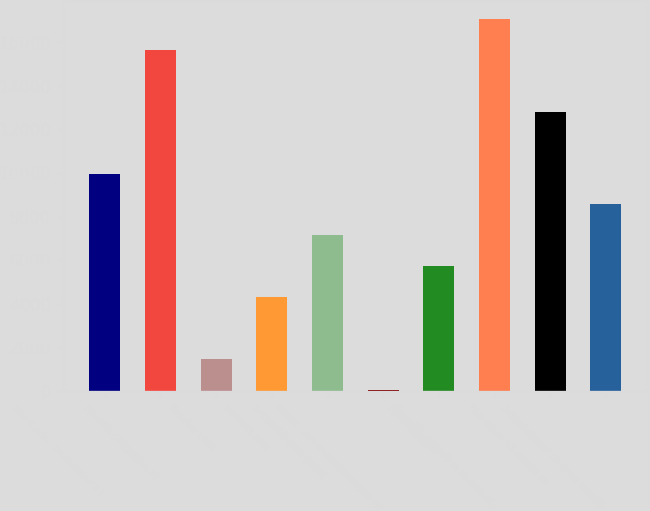Convert chart to OTSL. <chart><loc_0><loc_0><loc_500><loc_500><bar_chart><fcel>Year Ended December 31<fcel>Benefit obligation at<fcel>Service cost<fcel>Interest cost<fcel>Actuarial gain (loss)<fcel>Settlement/curtailment/other<fcel>Benefits paid<fcel>Benefit obligation at end of<fcel>Fair value of assets at<fcel>Actual return on plan assets<nl><fcel>9965.8<fcel>15627.4<fcel>1473.4<fcel>4304.2<fcel>7135<fcel>58<fcel>5719.6<fcel>17042.8<fcel>12796.6<fcel>8550.4<nl></chart> 